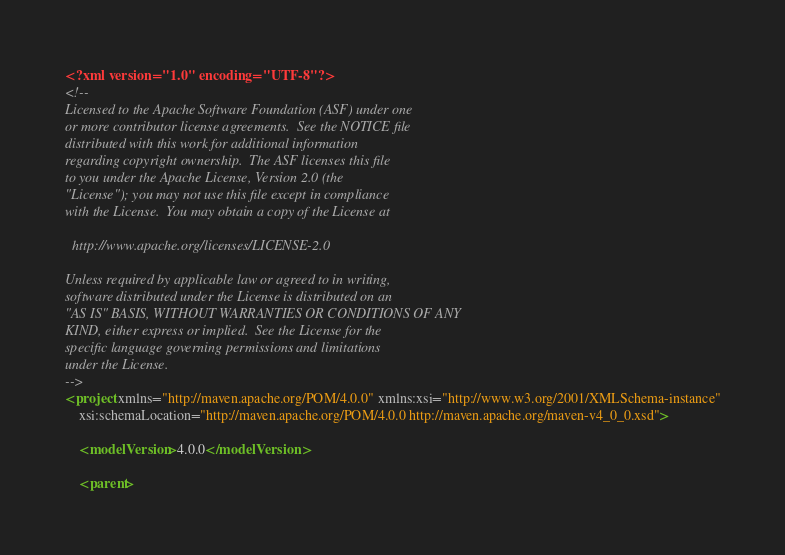<code> <loc_0><loc_0><loc_500><loc_500><_XML_><?xml version="1.0" encoding="UTF-8"?>
<!--
Licensed to the Apache Software Foundation (ASF) under one
or more contributor license agreements.  See the NOTICE file
distributed with this work for additional information
regarding copyright ownership.  The ASF licenses this file
to you under the Apache License, Version 2.0 (the
"License"); you may not use this file except in compliance
with the License.  You may obtain a copy of the License at

  http://www.apache.org/licenses/LICENSE-2.0

Unless required by applicable law or agreed to in writing,
software distributed under the License is distributed on an
"AS IS" BASIS, WITHOUT WARRANTIES OR CONDITIONS OF ANY
KIND, either express or implied.  See the License for the
specific language governing permissions and limitations
under the License.
-->
<project xmlns="http://maven.apache.org/POM/4.0.0" xmlns:xsi="http://www.w3.org/2001/XMLSchema-instance"
	xsi:schemaLocation="http://maven.apache.org/POM/4.0.0 http://maven.apache.org/maven-v4_0_0.xsd">

	<modelVersion>4.0.0</modelVersion>

	<parent></code> 